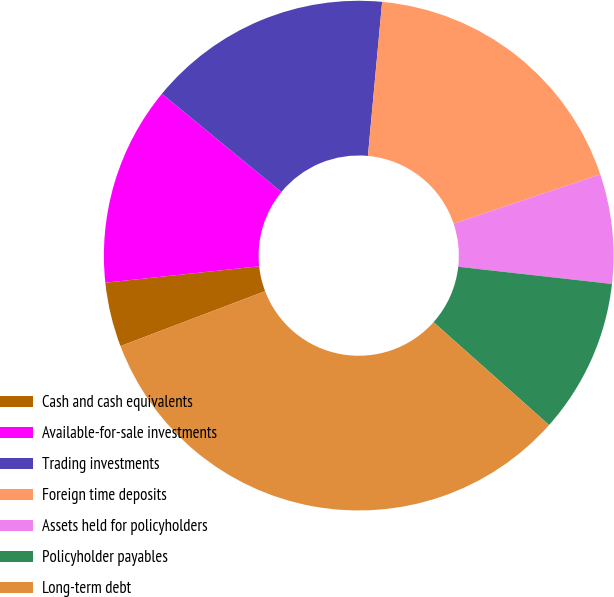Convert chart to OTSL. <chart><loc_0><loc_0><loc_500><loc_500><pie_chart><fcel>Cash and cash equivalents<fcel>Available-for-sale investments<fcel>Trading investments<fcel>Foreign time deposits<fcel>Assets held for policyholders<fcel>Policyholder payables<fcel>Long-term debt<nl><fcel>4.08%<fcel>12.65%<fcel>15.51%<fcel>18.37%<fcel>6.94%<fcel>9.8%<fcel>32.65%<nl></chart> 